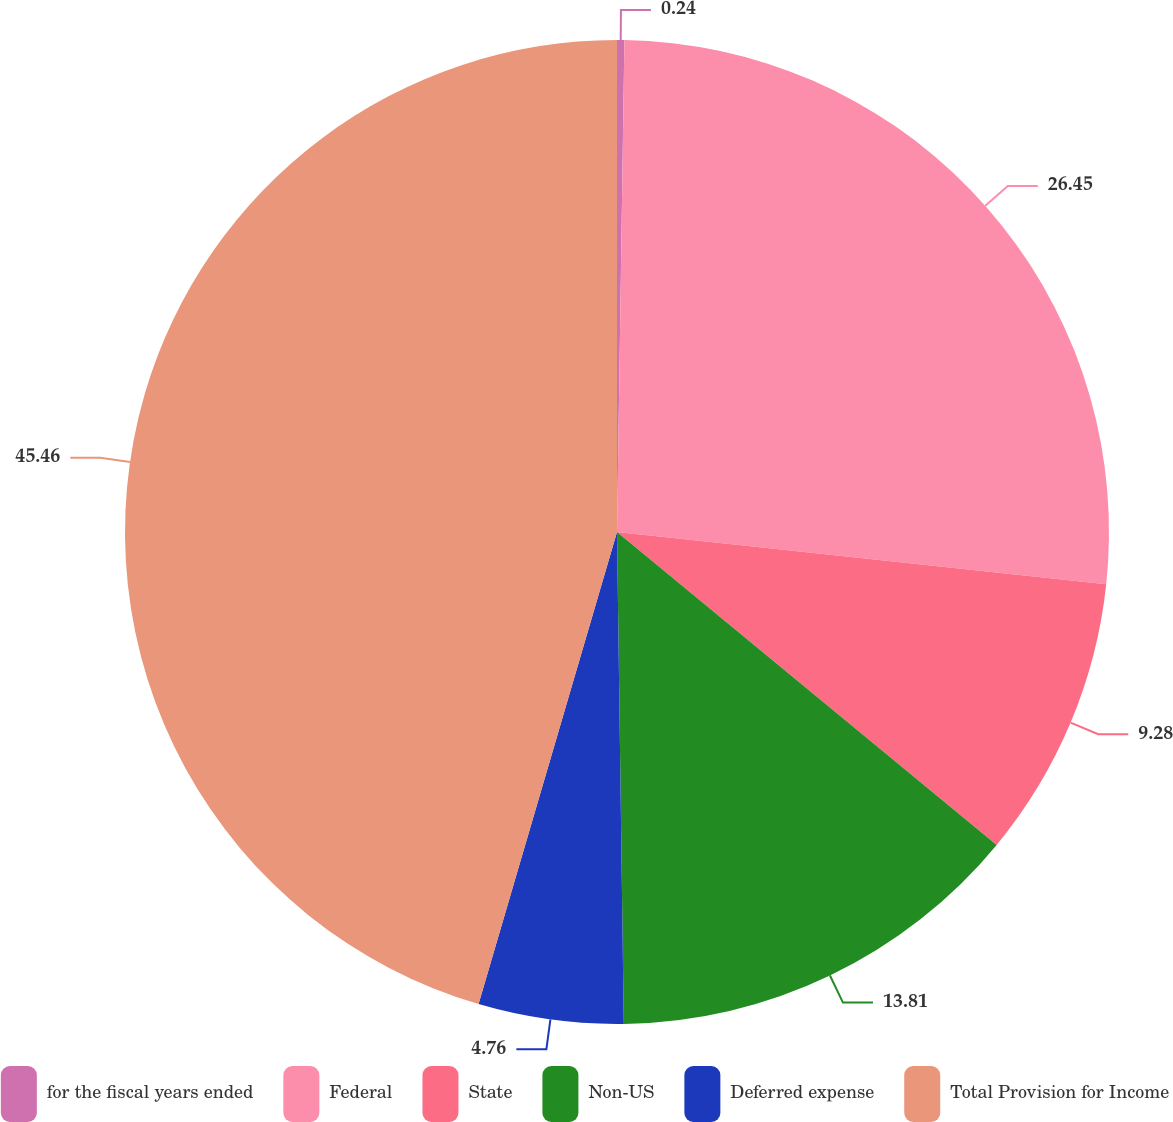Convert chart. <chart><loc_0><loc_0><loc_500><loc_500><pie_chart><fcel>for the fiscal years ended<fcel>Federal<fcel>State<fcel>Non-US<fcel>Deferred expense<fcel>Total Provision for Income<nl><fcel>0.24%<fcel>26.45%<fcel>9.28%<fcel>13.81%<fcel>4.76%<fcel>45.46%<nl></chart> 